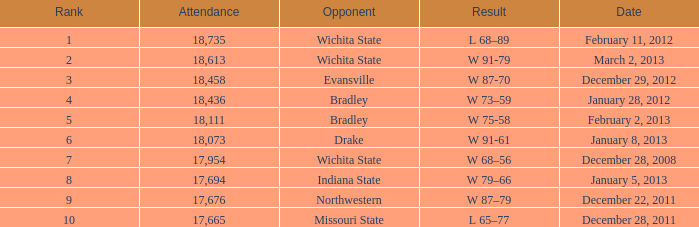What's the rank for February 11, 2012 with less than 18,735 in attendance? None. 